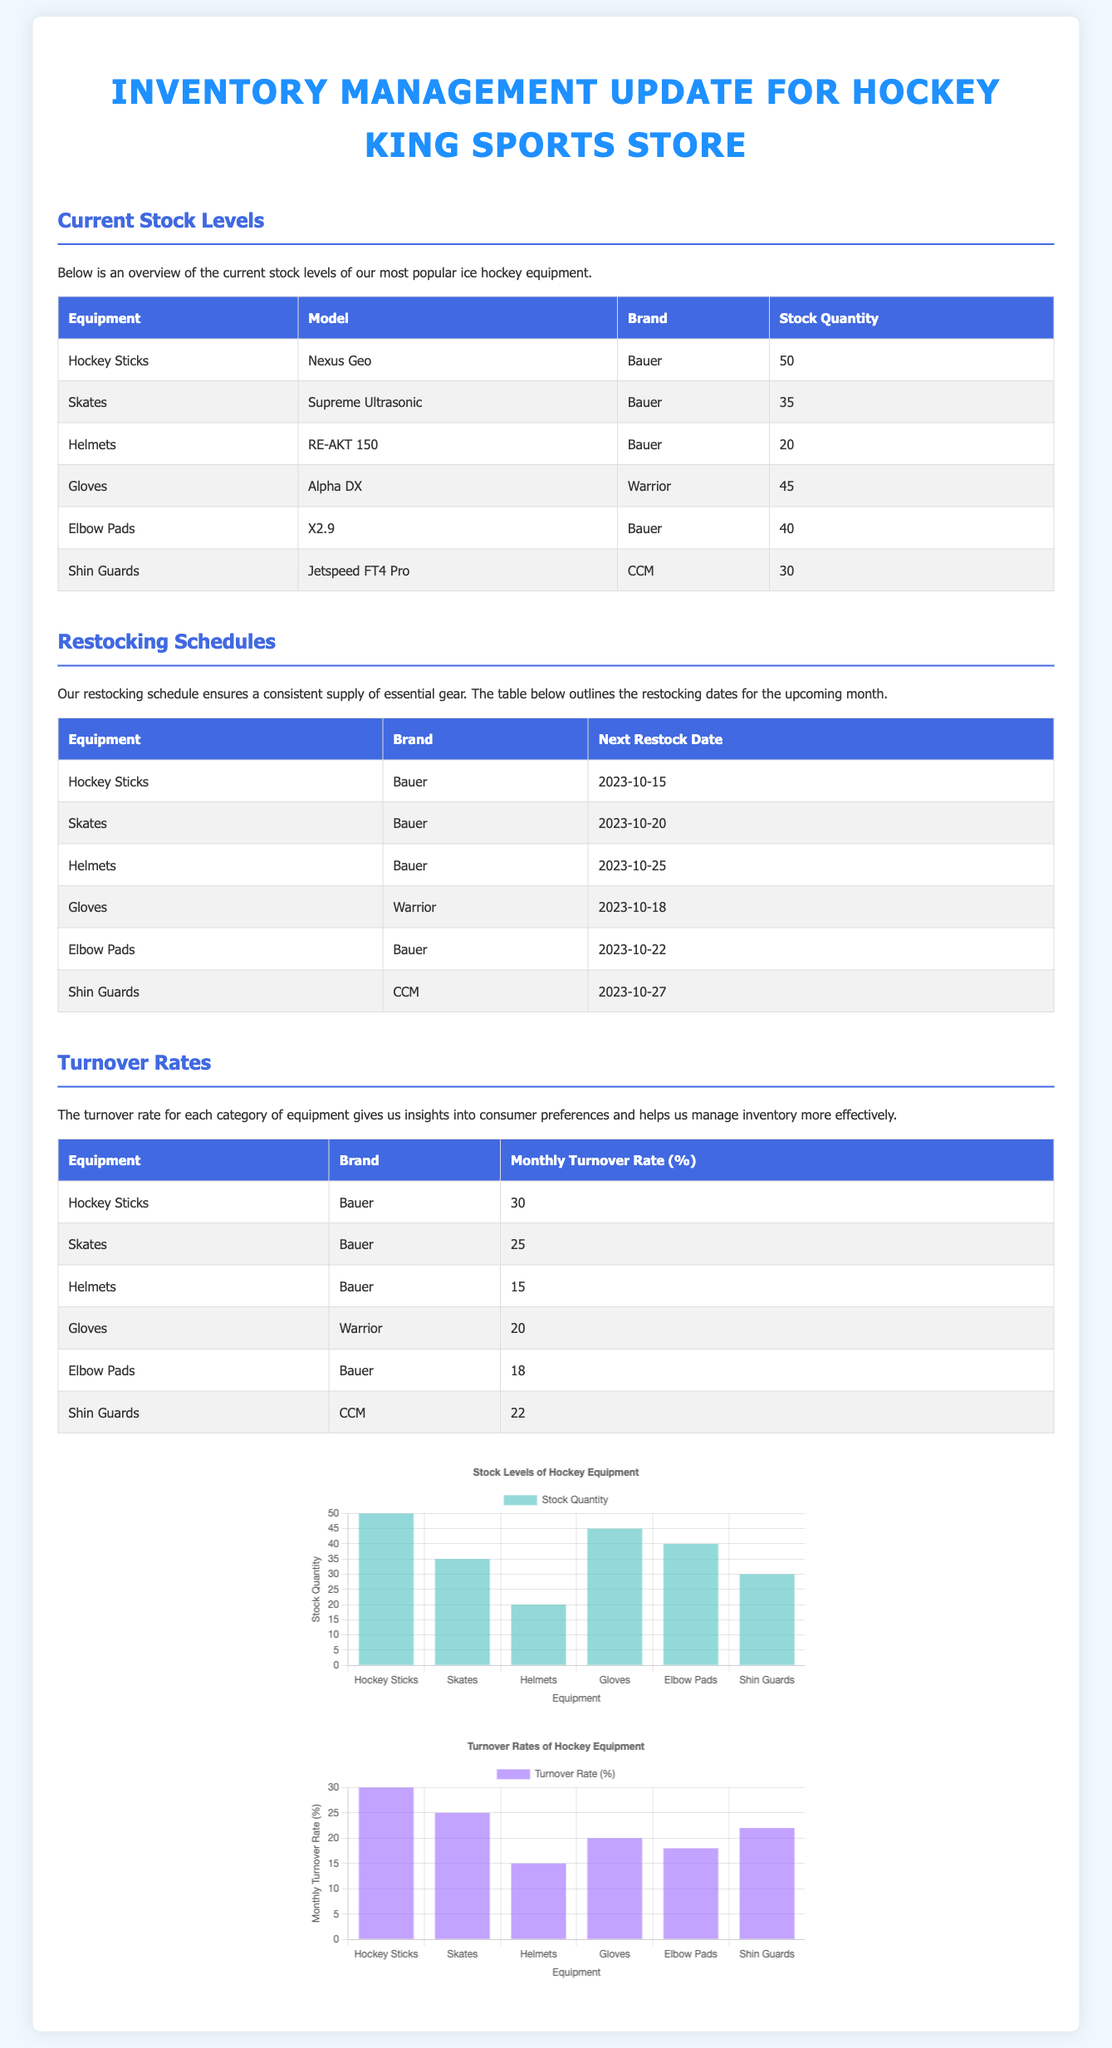What is the stock quantity of Hockey Sticks? The stock quantity of Hockey Sticks is directly listed in the inventory management update.
Answer: 50 When is the next restock date for Skates? The next restock date for Skates is specified in the restocking schedule table.
Answer: 2023-10-20 What is the monthly turnover rate for Helmets? The monthly turnover rate for Helmets can be found in the turnover rates section of the document.
Answer: 15 Which brand produces the gloves with the highest stock level? By reviewing the stock levels table, we see which brand corresponds to the gloves that have the most stock.
Answer: Warrior What equipment has the lowest stock quantity? The equipment with the lowest stock quantity is indicated in the inventory stock levels table.
Answer: Helmets What is the turnover rate for Shin Guards? The turnover rate for Shin Guards is detailed in the turnover rates table, providing the necessary percentage.
Answer: 22 How many pieces of Elbow Pads are currently in stock? The current stock quantity of Elbow Pads is listed in the inventory management update.
Answer: 40 Which equipment is scheduled for restocking on the 25th of October? The next restock date for equipment listed in the schedule will indicate which item falls on this particular date.
Answer: Helmets 